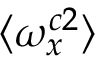Convert formula to latex. <formula><loc_0><loc_0><loc_500><loc_500>\langle \omega _ { x } ^ { c 2 } \rangle</formula> 